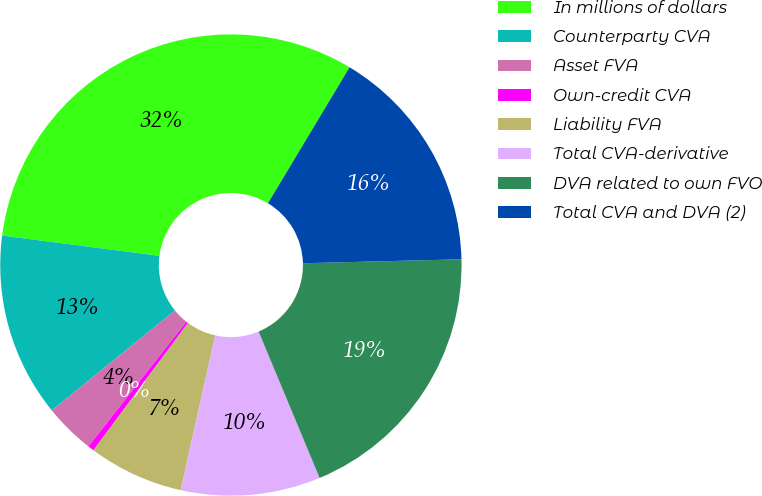<chart> <loc_0><loc_0><loc_500><loc_500><pie_chart><fcel>In millions of dollars<fcel>Counterparty CVA<fcel>Asset FVA<fcel>Own-credit CVA<fcel>Liability FVA<fcel>Total CVA-derivative<fcel>DVA related to own FVO<fcel>Total CVA and DVA (2)<nl><fcel>31.56%<fcel>12.89%<fcel>3.55%<fcel>0.44%<fcel>6.66%<fcel>9.78%<fcel>19.11%<fcel>16.0%<nl></chart> 